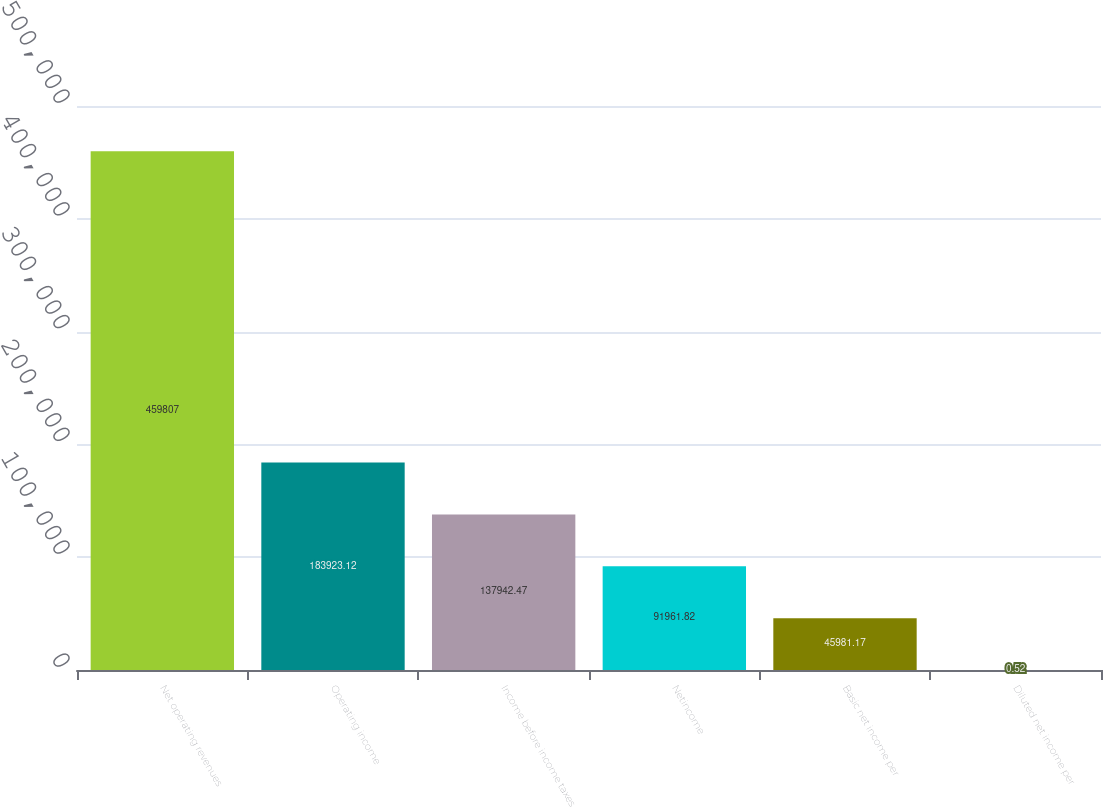Convert chart. <chart><loc_0><loc_0><loc_500><loc_500><bar_chart><fcel>Net operating revenues<fcel>Operating income<fcel>Income before income taxes<fcel>Netincome<fcel>Basic net income per<fcel>Diluted net income per<nl><fcel>459807<fcel>183923<fcel>137942<fcel>91961.8<fcel>45981.2<fcel>0.52<nl></chart> 